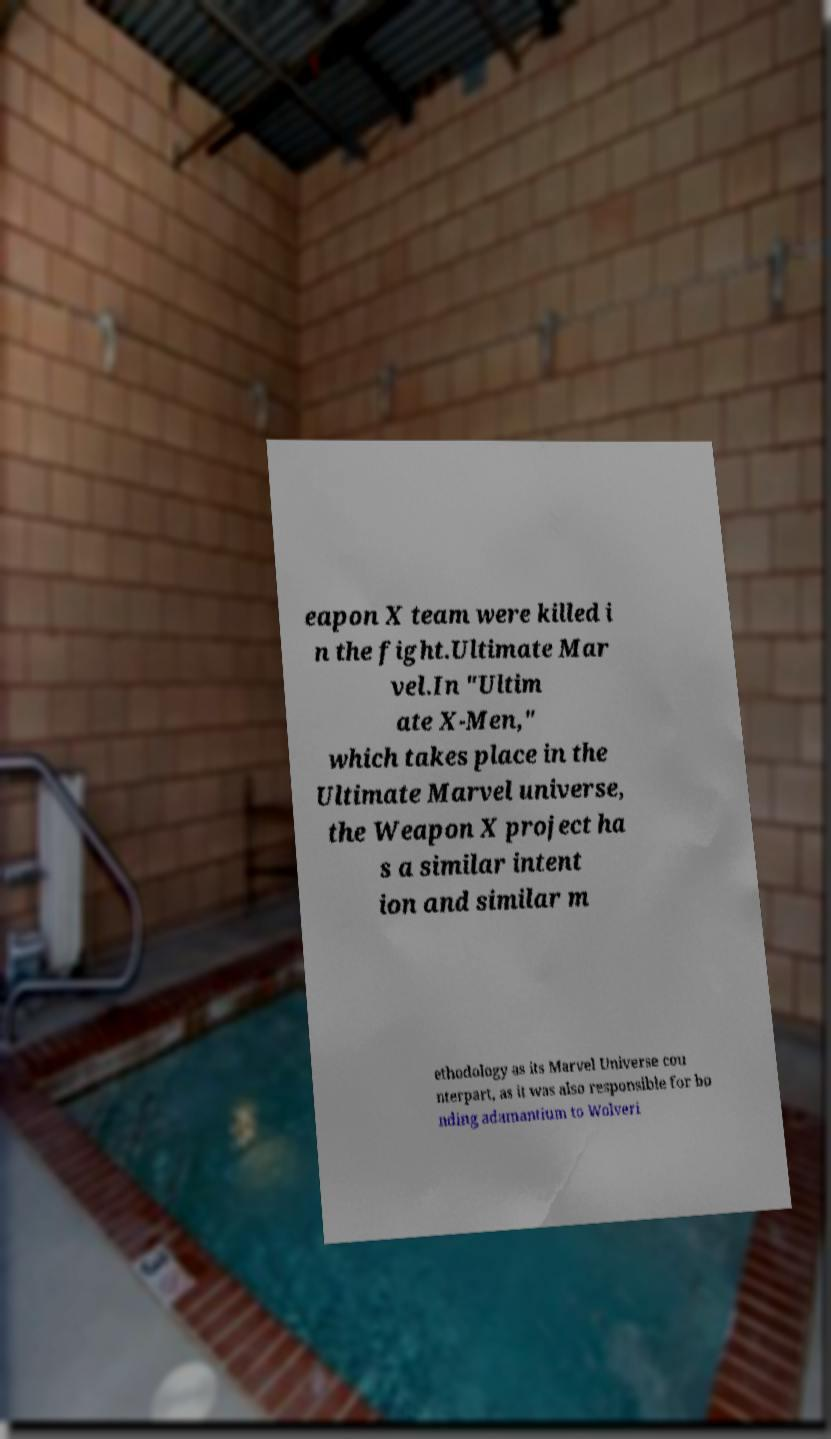Please read and relay the text visible in this image. What does it say? eapon X team were killed i n the fight.Ultimate Mar vel.In "Ultim ate X-Men," which takes place in the Ultimate Marvel universe, the Weapon X project ha s a similar intent ion and similar m ethodology as its Marvel Universe cou nterpart, as it was also responsible for bo nding adamantium to Wolveri 